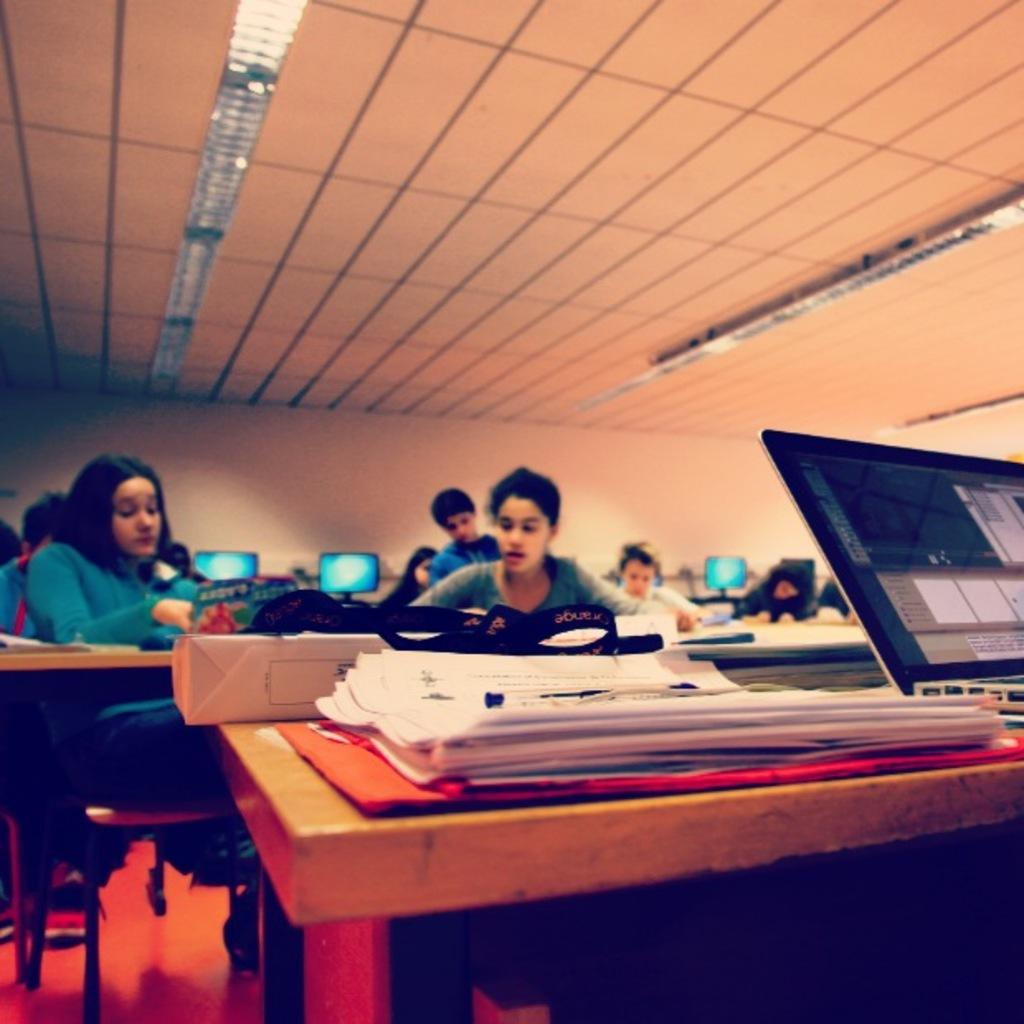What is happening in the image involving a group of people? The people in the image are sitting on benches and doing some work. What objects are in the foreground of the image? There is a laptop and papers in the foreground of the image. What might the people be using the laptop and papers for? The people might be using the laptop and papers for their work. Can you see a church in the background of the image? There is no church visible in the background of the image. What story is being told by the people in the image? The image does not depict a story being told; it shows people working on benches with a laptop and papers. 